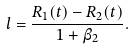Convert formula to latex. <formula><loc_0><loc_0><loc_500><loc_500>l = \frac { R _ { 1 } ( t ) - R _ { 2 } ( t ) } { 1 + \beta _ { 2 } } .</formula> 